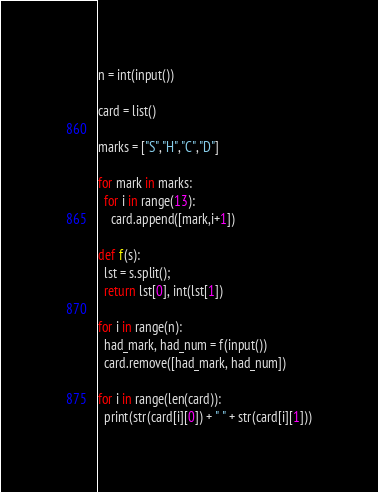<code> <loc_0><loc_0><loc_500><loc_500><_Python_>n = int(input())

card = list()

marks = ["S","H","C","D"]

for mark in marks:
  for i in range(13):
    card.append([mark,i+1])

def f(s):
  lst = s.split();
  return lst[0], int(lst[1])

for i in range(n):
  had_mark, had_num = f(input())
  card.remove([had_mark, had_num])

for i in range(len(card)):
  print(str(card[i][0]) + " " + str(card[i][1]))
</code> 